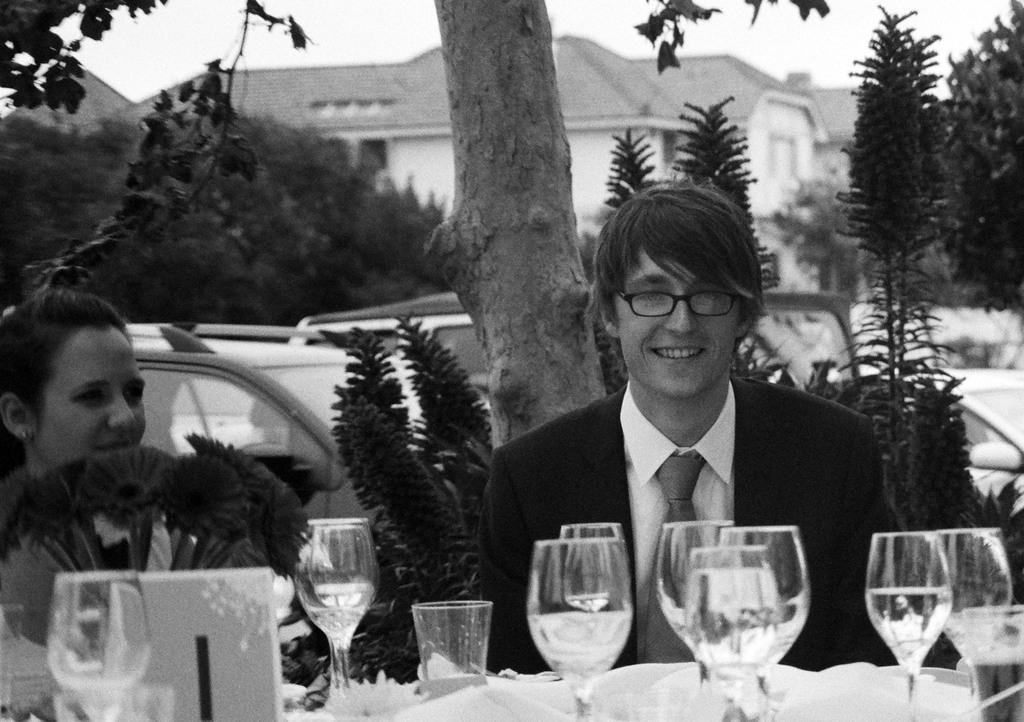What are the people in the image doing? There is a couple sitting in the image. What objects can be seen near the couple? There are glasses in the image. What type of natural environment is visible in the image? There are trees in the image. What type of structure is present in the image? There is a house in the image. What type of fowl can be seen walking around the couple in the image? There is no fowl present in the image; it only features a couple, glasses, trees, and a house. 